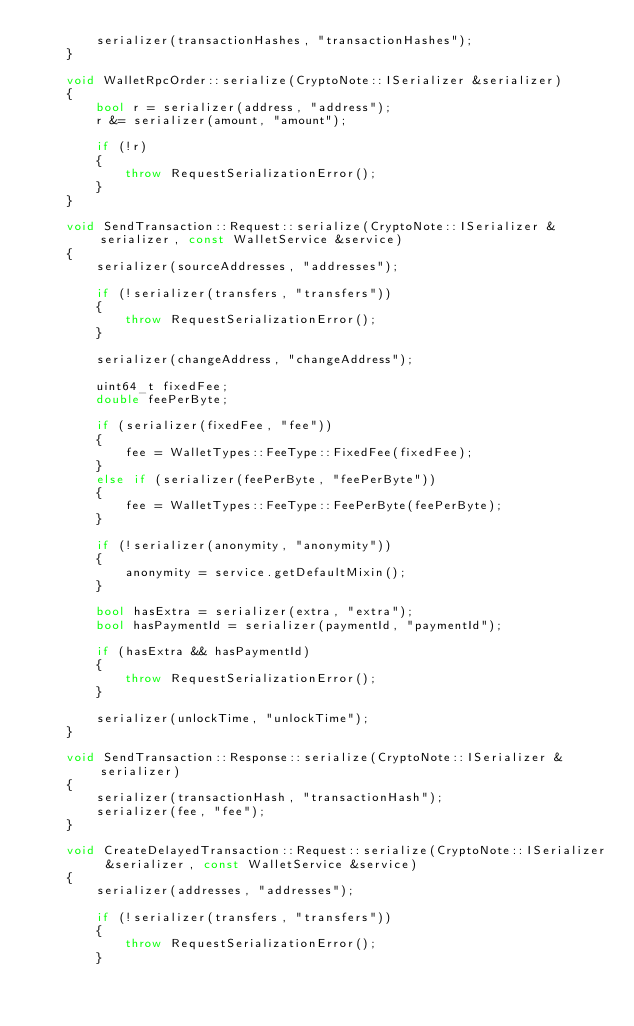<code> <loc_0><loc_0><loc_500><loc_500><_C++_>        serializer(transactionHashes, "transactionHashes");
    }

    void WalletRpcOrder::serialize(CryptoNote::ISerializer &serializer)
    {
        bool r = serializer(address, "address");
        r &= serializer(amount, "amount");

        if (!r)
        {
            throw RequestSerializationError();
        }
    }

    void SendTransaction::Request::serialize(CryptoNote::ISerializer &serializer, const WalletService &service)
    {
        serializer(sourceAddresses, "addresses");

        if (!serializer(transfers, "transfers"))
        {
            throw RequestSerializationError();
        }

        serializer(changeAddress, "changeAddress");

        uint64_t fixedFee;
        double feePerByte;

        if (serializer(fixedFee, "fee"))
        {
            fee = WalletTypes::FeeType::FixedFee(fixedFee);
        }
        else if (serializer(feePerByte, "feePerByte"))
        {
            fee = WalletTypes::FeeType::FeePerByte(feePerByte);
        }

        if (!serializer(anonymity, "anonymity"))
        {
            anonymity = service.getDefaultMixin();
        }

        bool hasExtra = serializer(extra, "extra");
        bool hasPaymentId = serializer(paymentId, "paymentId");

        if (hasExtra && hasPaymentId)
        {
            throw RequestSerializationError();
        }

        serializer(unlockTime, "unlockTime");
    }

    void SendTransaction::Response::serialize(CryptoNote::ISerializer &serializer)
    {
        serializer(transactionHash, "transactionHash");
        serializer(fee, "fee");
    }

    void CreateDelayedTransaction::Request::serialize(CryptoNote::ISerializer &serializer, const WalletService &service)
    {
        serializer(addresses, "addresses");

        if (!serializer(transfers, "transfers"))
        {
            throw RequestSerializationError();
        }
</code> 